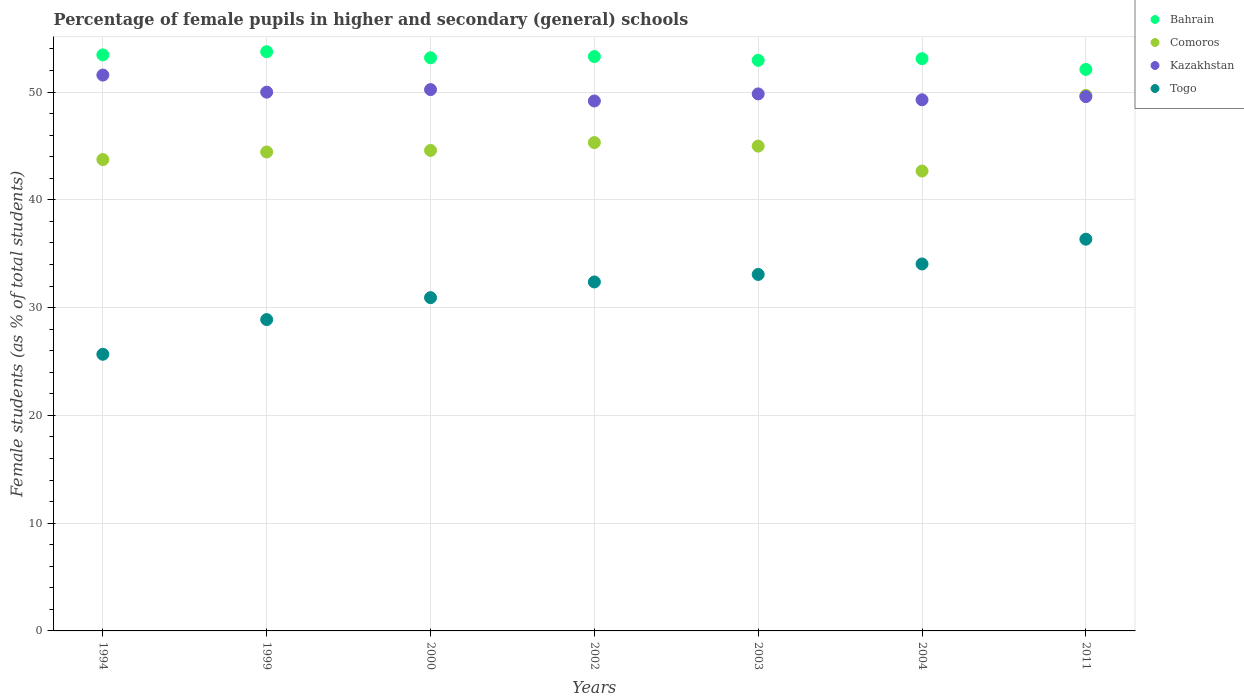How many different coloured dotlines are there?
Your answer should be very brief. 4. What is the percentage of female pupils in higher and secondary schools in Bahrain in 2002?
Make the answer very short. 53.3. Across all years, what is the maximum percentage of female pupils in higher and secondary schools in Comoros?
Ensure brevity in your answer.  49.69. Across all years, what is the minimum percentage of female pupils in higher and secondary schools in Kazakhstan?
Offer a terse response. 49.17. What is the total percentage of female pupils in higher and secondary schools in Bahrain in the graph?
Provide a succinct answer. 371.83. What is the difference between the percentage of female pupils in higher and secondary schools in Kazakhstan in 2003 and that in 2011?
Ensure brevity in your answer.  0.25. What is the difference between the percentage of female pupils in higher and secondary schools in Bahrain in 2011 and the percentage of female pupils in higher and secondary schools in Togo in 1994?
Your answer should be very brief. 26.43. What is the average percentage of female pupils in higher and secondary schools in Comoros per year?
Keep it short and to the point. 45.06. In the year 2000, what is the difference between the percentage of female pupils in higher and secondary schools in Togo and percentage of female pupils in higher and secondary schools in Kazakhstan?
Provide a succinct answer. -19.3. In how many years, is the percentage of female pupils in higher and secondary schools in Togo greater than 16 %?
Offer a terse response. 7. What is the ratio of the percentage of female pupils in higher and secondary schools in Comoros in 1994 to that in 2003?
Offer a very short reply. 0.97. Is the percentage of female pupils in higher and secondary schools in Kazakhstan in 2000 less than that in 2003?
Provide a short and direct response. No. What is the difference between the highest and the second highest percentage of female pupils in higher and secondary schools in Kazakhstan?
Make the answer very short. 1.35. What is the difference between the highest and the lowest percentage of female pupils in higher and secondary schools in Kazakhstan?
Provide a short and direct response. 2.4. Does the percentage of female pupils in higher and secondary schools in Bahrain monotonically increase over the years?
Your answer should be compact. No. Is the percentage of female pupils in higher and secondary schools in Kazakhstan strictly greater than the percentage of female pupils in higher and secondary schools in Bahrain over the years?
Offer a very short reply. No. How many years are there in the graph?
Give a very brief answer. 7. What is the difference between two consecutive major ticks on the Y-axis?
Your answer should be very brief. 10. Are the values on the major ticks of Y-axis written in scientific E-notation?
Keep it short and to the point. No. Does the graph contain grids?
Your answer should be compact. Yes. How many legend labels are there?
Your response must be concise. 4. How are the legend labels stacked?
Your response must be concise. Vertical. What is the title of the graph?
Make the answer very short. Percentage of female pupils in higher and secondary (general) schools. What is the label or title of the X-axis?
Keep it short and to the point. Years. What is the label or title of the Y-axis?
Your answer should be very brief. Female students (as % of total students). What is the Female students (as % of total students) in Bahrain in 1994?
Provide a short and direct response. 53.45. What is the Female students (as % of total students) in Comoros in 1994?
Offer a terse response. 43.74. What is the Female students (as % of total students) of Kazakhstan in 1994?
Offer a terse response. 51.58. What is the Female students (as % of total students) in Togo in 1994?
Keep it short and to the point. 25.67. What is the Female students (as % of total students) in Bahrain in 1999?
Provide a short and direct response. 53.75. What is the Female students (as % of total students) of Comoros in 1999?
Make the answer very short. 44.44. What is the Female students (as % of total students) in Kazakhstan in 1999?
Ensure brevity in your answer.  49.99. What is the Female students (as % of total students) in Togo in 1999?
Offer a terse response. 28.89. What is the Female students (as % of total students) of Bahrain in 2000?
Your answer should be compact. 53.18. What is the Female students (as % of total students) of Comoros in 2000?
Make the answer very short. 44.59. What is the Female students (as % of total students) of Kazakhstan in 2000?
Give a very brief answer. 50.23. What is the Female students (as % of total students) in Togo in 2000?
Offer a very short reply. 30.93. What is the Female students (as % of total students) of Bahrain in 2002?
Offer a very short reply. 53.3. What is the Female students (as % of total students) in Comoros in 2002?
Provide a succinct answer. 45.31. What is the Female students (as % of total students) in Kazakhstan in 2002?
Your answer should be very brief. 49.17. What is the Female students (as % of total students) of Togo in 2002?
Your response must be concise. 32.38. What is the Female students (as % of total students) of Bahrain in 2003?
Offer a very short reply. 52.95. What is the Female students (as % of total students) in Comoros in 2003?
Ensure brevity in your answer.  44.99. What is the Female students (as % of total students) of Kazakhstan in 2003?
Make the answer very short. 49.83. What is the Female students (as % of total students) of Togo in 2003?
Ensure brevity in your answer.  33.08. What is the Female students (as % of total students) in Bahrain in 2004?
Offer a terse response. 53.1. What is the Female students (as % of total students) in Comoros in 2004?
Your answer should be very brief. 42.67. What is the Female students (as % of total students) in Kazakhstan in 2004?
Offer a terse response. 49.29. What is the Female students (as % of total students) in Togo in 2004?
Provide a short and direct response. 34.05. What is the Female students (as % of total students) of Bahrain in 2011?
Your answer should be very brief. 52.1. What is the Female students (as % of total students) of Comoros in 2011?
Offer a very short reply. 49.69. What is the Female students (as % of total students) of Kazakhstan in 2011?
Give a very brief answer. 49.58. What is the Female students (as % of total students) in Togo in 2011?
Provide a succinct answer. 36.35. Across all years, what is the maximum Female students (as % of total students) in Bahrain?
Ensure brevity in your answer.  53.75. Across all years, what is the maximum Female students (as % of total students) in Comoros?
Your answer should be very brief. 49.69. Across all years, what is the maximum Female students (as % of total students) in Kazakhstan?
Your answer should be compact. 51.58. Across all years, what is the maximum Female students (as % of total students) of Togo?
Provide a succinct answer. 36.35. Across all years, what is the minimum Female students (as % of total students) of Bahrain?
Ensure brevity in your answer.  52.1. Across all years, what is the minimum Female students (as % of total students) of Comoros?
Offer a very short reply. 42.67. Across all years, what is the minimum Female students (as % of total students) of Kazakhstan?
Your response must be concise. 49.17. Across all years, what is the minimum Female students (as % of total students) in Togo?
Give a very brief answer. 25.67. What is the total Female students (as % of total students) in Bahrain in the graph?
Keep it short and to the point. 371.83. What is the total Female students (as % of total students) of Comoros in the graph?
Give a very brief answer. 315.43. What is the total Female students (as % of total students) in Kazakhstan in the graph?
Make the answer very short. 349.68. What is the total Female students (as % of total students) in Togo in the graph?
Offer a very short reply. 221.35. What is the difference between the Female students (as % of total students) in Bahrain in 1994 and that in 1999?
Provide a succinct answer. -0.3. What is the difference between the Female students (as % of total students) of Comoros in 1994 and that in 1999?
Keep it short and to the point. -0.7. What is the difference between the Female students (as % of total students) of Kazakhstan in 1994 and that in 1999?
Your response must be concise. 1.58. What is the difference between the Female students (as % of total students) in Togo in 1994 and that in 1999?
Keep it short and to the point. -3.22. What is the difference between the Female students (as % of total students) of Bahrain in 1994 and that in 2000?
Ensure brevity in your answer.  0.27. What is the difference between the Female students (as % of total students) in Comoros in 1994 and that in 2000?
Offer a terse response. -0.85. What is the difference between the Female students (as % of total students) of Kazakhstan in 1994 and that in 2000?
Provide a short and direct response. 1.35. What is the difference between the Female students (as % of total students) in Togo in 1994 and that in 2000?
Offer a very short reply. -5.25. What is the difference between the Female students (as % of total students) in Bahrain in 1994 and that in 2002?
Provide a succinct answer. 0.15. What is the difference between the Female students (as % of total students) in Comoros in 1994 and that in 2002?
Provide a short and direct response. -1.57. What is the difference between the Female students (as % of total students) of Kazakhstan in 1994 and that in 2002?
Your answer should be very brief. 2.4. What is the difference between the Female students (as % of total students) in Togo in 1994 and that in 2002?
Your response must be concise. -6.71. What is the difference between the Female students (as % of total students) of Bahrain in 1994 and that in 2003?
Give a very brief answer. 0.51. What is the difference between the Female students (as % of total students) of Comoros in 1994 and that in 2003?
Offer a terse response. -1.25. What is the difference between the Female students (as % of total students) in Kazakhstan in 1994 and that in 2003?
Your response must be concise. 1.75. What is the difference between the Female students (as % of total students) of Togo in 1994 and that in 2003?
Offer a terse response. -7.41. What is the difference between the Female students (as % of total students) in Bahrain in 1994 and that in 2004?
Your answer should be very brief. 0.35. What is the difference between the Female students (as % of total students) of Comoros in 1994 and that in 2004?
Offer a very short reply. 1.07. What is the difference between the Female students (as % of total students) of Kazakhstan in 1994 and that in 2004?
Offer a very short reply. 2.29. What is the difference between the Female students (as % of total students) in Togo in 1994 and that in 2004?
Offer a very short reply. -8.38. What is the difference between the Female students (as % of total students) of Bahrain in 1994 and that in 2011?
Your answer should be very brief. 1.35. What is the difference between the Female students (as % of total students) of Comoros in 1994 and that in 2011?
Make the answer very short. -5.95. What is the difference between the Female students (as % of total students) of Kazakhstan in 1994 and that in 2011?
Ensure brevity in your answer.  2. What is the difference between the Female students (as % of total students) of Togo in 1994 and that in 2011?
Your response must be concise. -10.68. What is the difference between the Female students (as % of total students) in Bahrain in 1999 and that in 2000?
Ensure brevity in your answer.  0.56. What is the difference between the Female students (as % of total students) of Comoros in 1999 and that in 2000?
Your response must be concise. -0.15. What is the difference between the Female students (as % of total students) in Kazakhstan in 1999 and that in 2000?
Make the answer very short. -0.24. What is the difference between the Female students (as % of total students) of Togo in 1999 and that in 2000?
Make the answer very short. -2.04. What is the difference between the Female students (as % of total students) in Bahrain in 1999 and that in 2002?
Your answer should be compact. 0.45. What is the difference between the Female students (as % of total students) in Comoros in 1999 and that in 2002?
Keep it short and to the point. -0.87. What is the difference between the Female students (as % of total students) in Kazakhstan in 1999 and that in 2002?
Provide a short and direct response. 0.82. What is the difference between the Female students (as % of total students) of Togo in 1999 and that in 2002?
Provide a short and direct response. -3.49. What is the difference between the Female students (as % of total students) of Bahrain in 1999 and that in 2003?
Keep it short and to the point. 0.8. What is the difference between the Female students (as % of total students) of Comoros in 1999 and that in 2003?
Your response must be concise. -0.54. What is the difference between the Female students (as % of total students) of Kazakhstan in 1999 and that in 2003?
Keep it short and to the point. 0.16. What is the difference between the Female students (as % of total students) in Togo in 1999 and that in 2003?
Your answer should be compact. -4.19. What is the difference between the Female students (as % of total students) in Bahrain in 1999 and that in 2004?
Offer a very short reply. 0.65. What is the difference between the Female students (as % of total students) in Comoros in 1999 and that in 2004?
Keep it short and to the point. 1.77. What is the difference between the Female students (as % of total students) in Kazakhstan in 1999 and that in 2004?
Ensure brevity in your answer.  0.71. What is the difference between the Female students (as % of total students) of Togo in 1999 and that in 2004?
Ensure brevity in your answer.  -5.16. What is the difference between the Female students (as % of total students) in Bahrain in 1999 and that in 2011?
Offer a terse response. 1.64. What is the difference between the Female students (as % of total students) of Comoros in 1999 and that in 2011?
Provide a succinct answer. -5.25. What is the difference between the Female students (as % of total students) of Kazakhstan in 1999 and that in 2011?
Your answer should be compact. 0.41. What is the difference between the Female students (as % of total students) in Togo in 1999 and that in 2011?
Your response must be concise. -7.46. What is the difference between the Female students (as % of total students) of Bahrain in 2000 and that in 2002?
Your answer should be compact. -0.11. What is the difference between the Female students (as % of total students) of Comoros in 2000 and that in 2002?
Provide a short and direct response. -0.73. What is the difference between the Female students (as % of total students) in Kazakhstan in 2000 and that in 2002?
Keep it short and to the point. 1.06. What is the difference between the Female students (as % of total students) of Togo in 2000 and that in 2002?
Give a very brief answer. -1.46. What is the difference between the Female students (as % of total students) of Bahrain in 2000 and that in 2003?
Your answer should be very brief. 0.24. What is the difference between the Female students (as % of total students) in Comoros in 2000 and that in 2003?
Your response must be concise. -0.4. What is the difference between the Female students (as % of total students) in Kazakhstan in 2000 and that in 2003?
Provide a succinct answer. 0.4. What is the difference between the Female students (as % of total students) in Togo in 2000 and that in 2003?
Your answer should be compact. -2.15. What is the difference between the Female students (as % of total students) in Bahrain in 2000 and that in 2004?
Keep it short and to the point. 0.09. What is the difference between the Female students (as % of total students) of Comoros in 2000 and that in 2004?
Keep it short and to the point. 1.91. What is the difference between the Female students (as % of total students) in Kazakhstan in 2000 and that in 2004?
Provide a short and direct response. 0.95. What is the difference between the Female students (as % of total students) of Togo in 2000 and that in 2004?
Keep it short and to the point. -3.13. What is the difference between the Female students (as % of total students) of Bahrain in 2000 and that in 2011?
Give a very brief answer. 1.08. What is the difference between the Female students (as % of total students) of Comoros in 2000 and that in 2011?
Provide a short and direct response. -5.11. What is the difference between the Female students (as % of total students) in Kazakhstan in 2000 and that in 2011?
Offer a very short reply. 0.65. What is the difference between the Female students (as % of total students) of Togo in 2000 and that in 2011?
Offer a very short reply. -5.42. What is the difference between the Female students (as % of total students) of Bahrain in 2002 and that in 2003?
Provide a succinct answer. 0.35. What is the difference between the Female students (as % of total students) in Comoros in 2002 and that in 2003?
Your answer should be very brief. 0.33. What is the difference between the Female students (as % of total students) of Kazakhstan in 2002 and that in 2003?
Offer a very short reply. -0.66. What is the difference between the Female students (as % of total students) in Togo in 2002 and that in 2003?
Give a very brief answer. -0.7. What is the difference between the Female students (as % of total students) in Bahrain in 2002 and that in 2004?
Provide a succinct answer. 0.2. What is the difference between the Female students (as % of total students) in Comoros in 2002 and that in 2004?
Offer a terse response. 2.64. What is the difference between the Female students (as % of total students) of Kazakhstan in 2002 and that in 2004?
Your answer should be very brief. -0.11. What is the difference between the Female students (as % of total students) in Togo in 2002 and that in 2004?
Keep it short and to the point. -1.67. What is the difference between the Female students (as % of total students) in Bahrain in 2002 and that in 2011?
Your response must be concise. 1.19. What is the difference between the Female students (as % of total students) of Comoros in 2002 and that in 2011?
Make the answer very short. -4.38. What is the difference between the Female students (as % of total students) in Kazakhstan in 2002 and that in 2011?
Your response must be concise. -0.41. What is the difference between the Female students (as % of total students) of Togo in 2002 and that in 2011?
Give a very brief answer. -3.97. What is the difference between the Female students (as % of total students) in Bahrain in 2003 and that in 2004?
Offer a terse response. -0.15. What is the difference between the Female students (as % of total students) of Comoros in 2003 and that in 2004?
Provide a succinct answer. 2.31. What is the difference between the Female students (as % of total students) in Kazakhstan in 2003 and that in 2004?
Make the answer very short. 0.55. What is the difference between the Female students (as % of total students) of Togo in 2003 and that in 2004?
Make the answer very short. -0.97. What is the difference between the Female students (as % of total students) in Bahrain in 2003 and that in 2011?
Give a very brief answer. 0.84. What is the difference between the Female students (as % of total students) in Comoros in 2003 and that in 2011?
Ensure brevity in your answer.  -4.71. What is the difference between the Female students (as % of total students) in Kazakhstan in 2003 and that in 2011?
Make the answer very short. 0.25. What is the difference between the Female students (as % of total students) in Togo in 2003 and that in 2011?
Ensure brevity in your answer.  -3.27. What is the difference between the Female students (as % of total students) in Bahrain in 2004 and that in 2011?
Offer a very short reply. 0.99. What is the difference between the Female students (as % of total students) of Comoros in 2004 and that in 2011?
Keep it short and to the point. -7.02. What is the difference between the Female students (as % of total students) in Kazakhstan in 2004 and that in 2011?
Ensure brevity in your answer.  -0.3. What is the difference between the Female students (as % of total students) in Togo in 2004 and that in 2011?
Provide a short and direct response. -2.3. What is the difference between the Female students (as % of total students) of Bahrain in 1994 and the Female students (as % of total students) of Comoros in 1999?
Ensure brevity in your answer.  9.01. What is the difference between the Female students (as % of total students) of Bahrain in 1994 and the Female students (as % of total students) of Kazakhstan in 1999?
Offer a terse response. 3.46. What is the difference between the Female students (as % of total students) in Bahrain in 1994 and the Female students (as % of total students) in Togo in 1999?
Give a very brief answer. 24.56. What is the difference between the Female students (as % of total students) in Comoros in 1994 and the Female students (as % of total students) in Kazakhstan in 1999?
Ensure brevity in your answer.  -6.26. What is the difference between the Female students (as % of total students) in Comoros in 1994 and the Female students (as % of total students) in Togo in 1999?
Keep it short and to the point. 14.85. What is the difference between the Female students (as % of total students) of Kazakhstan in 1994 and the Female students (as % of total students) of Togo in 1999?
Keep it short and to the point. 22.69. What is the difference between the Female students (as % of total students) in Bahrain in 1994 and the Female students (as % of total students) in Comoros in 2000?
Your answer should be compact. 8.86. What is the difference between the Female students (as % of total students) in Bahrain in 1994 and the Female students (as % of total students) in Kazakhstan in 2000?
Offer a very short reply. 3.22. What is the difference between the Female students (as % of total students) in Bahrain in 1994 and the Female students (as % of total students) in Togo in 2000?
Your answer should be very brief. 22.53. What is the difference between the Female students (as % of total students) in Comoros in 1994 and the Female students (as % of total students) in Kazakhstan in 2000?
Your response must be concise. -6.49. What is the difference between the Female students (as % of total students) in Comoros in 1994 and the Female students (as % of total students) in Togo in 2000?
Keep it short and to the point. 12.81. What is the difference between the Female students (as % of total students) in Kazakhstan in 1994 and the Female students (as % of total students) in Togo in 2000?
Give a very brief answer. 20.65. What is the difference between the Female students (as % of total students) of Bahrain in 1994 and the Female students (as % of total students) of Comoros in 2002?
Offer a very short reply. 8.14. What is the difference between the Female students (as % of total students) of Bahrain in 1994 and the Female students (as % of total students) of Kazakhstan in 2002?
Your response must be concise. 4.28. What is the difference between the Female students (as % of total students) in Bahrain in 1994 and the Female students (as % of total students) in Togo in 2002?
Offer a very short reply. 21.07. What is the difference between the Female students (as % of total students) in Comoros in 1994 and the Female students (as % of total students) in Kazakhstan in 2002?
Provide a succinct answer. -5.44. What is the difference between the Female students (as % of total students) of Comoros in 1994 and the Female students (as % of total students) of Togo in 2002?
Offer a very short reply. 11.36. What is the difference between the Female students (as % of total students) of Kazakhstan in 1994 and the Female students (as % of total students) of Togo in 2002?
Make the answer very short. 19.2. What is the difference between the Female students (as % of total students) in Bahrain in 1994 and the Female students (as % of total students) in Comoros in 2003?
Offer a very short reply. 8.47. What is the difference between the Female students (as % of total students) of Bahrain in 1994 and the Female students (as % of total students) of Kazakhstan in 2003?
Your response must be concise. 3.62. What is the difference between the Female students (as % of total students) in Bahrain in 1994 and the Female students (as % of total students) in Togo in 2003?
Your answer should be compact. 20.37. What is the difference between the Female students (as % of total students) in Comoros in 1994 and the Female students (as % of total students) in Kazakhstan in 2003?
Ensure brevity in your answer.  -6.09. What is the difference between the Female students (as % of total students) of Comoros in 1994 and the Female students (as % of total students) of Togo in 2003?
Provide a short and direct response. 10.66. What is the difference between the Female students (as % of total students) of Kazakhstan in 1994 and the Female students (as % of total students) of Togo in 2003?
Provide a succinct answer. 18.5. What is the difference between the Female students (as % of total students) in Bahrain in 1994 and the Female students (as % of total students) in Comoros in 2004?
Ensure brevity in your answer.  10.78. What is the difference between the Female students (as % of total students) of Bahrain in 1994 and the Female students (as % of total students) of Kazakhstan in 2004?
Your answer should be compact. 4.17. What is the difference between the Female students (as % of total students) in Bahrain in 1994 and the Female students (as % of total students) in Togo in 2004?
Your response must be concise. 19.4. What is the difference between the Female students (as % of total students) of Comoros in 1994 and the Female students (as % of total students) of Kazakhstan in 2004?
Keep it short and to the point. -5.55. What is the difference between the Female students (as % of total students) in Comoros in 1994 and the Female students (as % of total students) in Togo in 2004?
Ensure brevity in your answer.  9.69. What is the difference between the Female students (as % of total students) in Kazakhstan in 1994 and the Female students (as % of total students) in Togo in 2004?
Your answer should be very brief. 17.53. What is the difference between the Female students (as % of total students) of Bahrain in 1994 and the Female students (as % of total students) of Comoros in 2011?
Keep it short and to the point. 3.76. What is the difference between the Female students (as % of total students) in Bahrain in 1994 and the Female students (as % of total students) in Kazakhstan in 2011?
Offer a very short reply. 3.87. What is the difference between the Female students (as % of total students) in Bahrain in 1994 and the Female students (as % of total students) in Togo in 2011?
Your answer should be compact. 17.1. What is the difference between the Female students (as % of total students) in Comoros in 1994 and the Female students (as % of total students) in Kazakhstan in 2011?
Offer a very short reply. -5.84. What is the difference between the Female students (as % of total students) in Comoros in 1994 and the Female students (as % of total students) in Togo in 2011?
Your answer should be compact. 7.39. What is the difference between the Female students (as % of total students) in Kazakhstan in 1994 and the Female students (as % of total students) in Togo in 2011?
Provide a short and direct response. 15.23. What is the difference between the Female students (as % of total students) of Bahrain in 1999 and the Female students (as % of total students) of Comoros in 2000?
Provide a succinct answer. 9.16. What is the difference between the Female students (as % of total students) of Bahrain in 1999 and the Female students (as % of total students) of Kazakhstan in 2000?
Your response must be concise. 3.52. What is the difference between the Female students (as % of total students) in Bahrain in 1999 and the Female students (as % of total students) in Togo in 2000?
Offer a terse response. 22.82. What is the difference between the Female students (as % of total students) in Comoros in 1999 and the Female students (as % of total students) in Kazakhstan in 2000?
Your response must be concise. -5.79. What is the difference between the Female students (as % of total students) in Comoros in 1999 and the Female students (as % of total students) in Togo in 2000?
Your response must be concise. 13.52. What is the difference between the Female students (as % of total students) of Kazakhstan in 1999 and the Female students (as % of total students) of Togo in 2000?
Provide a succinct answer. 19.07. What is the difference between the Female students (as % of total students) of Bahrain in 1999 and the Female students (as % of total students) of Comoros in 2002?
Give a very brief answer. 8.43. What is the difference between the Female students (as % of total students) of Bahrain in 1999 and the Female students (as % of total students) of Kazakhstan in 2002?
Provide a short and direct response. 4.57. What is the difference between the Female students (as % of total students) of Bahrain in 1999 and the Female students (as % of total students) of Togo in 2002?
Your response must be concise. 21.37. What is the difference between the Female students (as % of total students) of Comoros in 1999 and the Female students (as % of total students) of Kazakhstan in 2002?
Make the answer very short. -4.73. What is the difference between the Female students (as % of total students) in Comoros in 1999 and the Female students (as % of total students) in Togo in 2002?
Your answer should be very brief. 12.06. What is the difference between the Female students (as % of total students) in Kazakhstan in 1999 and the Female students (as % of total students) in Togo in 2002?
Offer a very short reply. 17.61. What is the difference between the Female students (as % of total students) of Bahrain in 1999 and the Female students (as % of total students) of Comoros in 2003?
Your response must be concise. 8.76. What is the difference between the Female students (as % of total students) in Bahrain in 1999 and the Female students (as % of total students) in Kazakhstan in 2003?
Ensure brevity in your answer.  3.92. What is the difference between the Female students (as % of total students) in Bahrain in 1999 and the Female students (as % of total students) in Togo in 2003?
Provide a succinct answer. 20.67. What is the difference between the Female students (as % of total students) in Comoros in 1999 and the Female students (as % of total students) in Kazakhstan in 2003?
Your response must be concise. -5.39. What is the difference between the Female students (as % of total students) of Comoros in 1999 and the Female students (as % of total students) of Togo in 2003?
Ensure brevity in your answer.  11.36. What is the difference between the Female students (as % of total students) in Kazakhstan in 1999 and the Female students (as % of total students) in Togo in 2003?
Your response must be concise. 16.91. What is the difference between the Female students (as % of total students) in Bahrain in 1999 and the Female students (as % of total students) in Comoros in 2004?
Provide a short and direct response. 11.07. What is the difference between the Female students (as % of total students) in Bahrain in 1999 and the Female students (as % of total students) in Kazakhstan in 2004?
Your answer should be compact. 4.46. What is the difference between the Female students (as % of total students) in Bahrain in 1999 and the Female students (as % of total students) in Togo in 2004?
Provide a short and direct response. 19.7. What is the difference between the Female students (as % of total students) of Comoros in 1999 and the Female students (as % of total students) of Kazakhstan in 2004?
Give a very brief answer. -4.84. What is the difference between the Female students (as % of total students) of Comoros in 1999 and the Female students (as % of total students) of Togo in 2004?
Ensure brevity in your answer.  10.39. What is the difference between the Female students (as % of total students) in Kazakhstan in 1999 and the Female students (as % of total students) in Togo in 2004?
Give a very brief answer. 15.94. What is the difference between the Female students (as % of total students) in Bahrain in 1999 and the Female students (as % of total students) in Comoros in 2011?
Keep it short and to the point. 4.06. What is the difference between the Female students (as % of total students) of Bahrain in 1999 and the Female students (as % of total students) of Kazakhstan in 2011?
Offer a terse response. 4.17. What is the difference between the Female students (as % of total students) of Bahrain in 1999 and the Female students (as % of total students) of Togo in 2011?
Provide a succinct answer. 17.4. What is the difference between the Female students (as % of total students) in Comoros in 1999 and the Female students (as % of total students) in Kazakhstan in 2011?
Offer a very short reply. -5.14. What is the difference between the Female students (as % of total students) in Comoros in 1999 and the Female students (as % of total students) in Togo in 2011?
Ensure brevity in your answer.  8.09. What is the difference between the Female students (as % of total students) in Kazakhstan in 1999 and the Female students (as % of total students) in Togo in 2011?
Provide a short and direct response. 13.65. What is the difference between the Female students (as % of total students) in Bahrain in 2000 and the Female students (as % of total students) in Comoros in 2002?
Your response must be concise. 7.87. What is the difference between the Female students (as % of total students) in Bahrain in 2000 and the Female students (as % of total students) in Kazakhstan in 2002?
Keep it short and to the point. 4.01. What is the difference between the Female students (as % of total students) in Bahrain in 2000 and the Female students (as % of total students) in Togo in 2002?
Provide a short and direct response. 20.8. What is the difference between the Female students (as % of total students) of Comoros in 2000 and the Female students (as % of total students) of Kazakhstan in 2002?
Provide a succinct answer. -4.59. What is the difference between the Female students (as % of total students) of Comoros in 2000 and the Female students (as % of total students) of Togo in 2002?
Your response must be concise. 12.2. What is the difference between the Female students (as % of total students) of Kazakhstan in 2000 and the Female students (as % of total students) of Togo in 2002?
Ensure brevity in your answer.  17.85. What is the difference between the Female students (as % of total students) in Bahrain in 2000 and the Female students (as % of total students) in Comoros in 2003?
Offer a very short reply. 8.2. What is the difference between the Female students (as % of total students) of Bahrain in 2000 and the Female students (as % of total students) of Kazakhstan in 2003?
Give a very brief answer. 3.35. What is the difference between the Female students (as % of total students) in Bahrain in 2000 and the Female students (as % of total students) in Togo in 2003?
Make the answer very short. 20.11. What is the difference between the Female students (as % of total students) of Comoros in 2000 and the Female students (as % of total students) of Kazakhstan in 2003?
Keep it short and to the point. -5.24. What is the difference between the Female students (as % of total students) of Comoros in 2000 and the Female students (as % of total students) of Togo in 2003?
Provide a short and direct response. 11.51. What is the difference between the Female students (as % of total students) of Kazakhstan in 2000 and the Female students (as % of total students) of Togo in 2003?
Your answer should be very brief. 17.15. What is the difference between the Female students (as % of total students) of Bahrain in 2000 and the Female students (as % of total students) of Comoros in 2004?
Ensure brevity in your answer.  10.51. What is the difference between the Female students (as % of total students) of Bahrain in 2000 and the Female students (as % of total students) of Kazakhstan in 2004?
Provide a short and direct response. 3.9. What is the difference between the Female students (as % of total students) of Bahrain in 2000 and the Female students (as % of total students) of Togo in 2004?
Offer a terse response. 19.13. What is the difference between the Female students (as % of total students) of Comoros in 2000 and the Female students (as % of total students) of Kazakhstan in 2004?
Provide a succinct answer. -4.7. What is the difference between the Female students (as % of total students) of Comoros in 2000 and the Female students (as % of total students) of Togo in 2004?
Ensure brevity in your answer.  10.54. What is the difference between the Female students (as % of total students) in Kazakhstan in 2000 and the Female students (as % of total students) in Togo in 2004?
Provide a short and direct response. 16.18. What is the difference between the Female students (as % of total students) of Bahrain in 2000 and the Female students (as % of total students) of Comoros in 2011?
Your answer should be compact. 3.49. What is the difference between the Female students (as % of total students) of Bahrain in 2000 and the Female students (as % of total students) of Kazakhstan in 2011?
Make the answer very short. 3.6. What is the difference between the Female students (as % of total students) of Bahrain in 2000 and the Female students (as % of total students) of Togo in 2011?
Give a very brief answer. 16.84. What is the difference between the Female students (as % of total students) in Comoros in 2000 and the Female students (as % of total students) in Kazakhstan in 2011?
Offer a very short reply. -4.99. What is the difference between the Female students (as % of total students) in Comoros in 2000 and the Female students (as % of total students) in Togo in 2011?
Provide a succinct answer. 8.24. What is the difference between the Female students (as % of total students) of Kazakhstan in 2000 and the Female students (as % of total students) of Togo in 2011?
Make the answer very short. 13.88. What is the difference between the Female students (as % of total students) of Bahrain in 2002 and the Female students (as % of total students) of Comoros in 2003?
Offer a terse response. 8.31. What is the difference between the Female students (as % of total students) of Bahrain in 2002 and the Female students (as % of total students) of Kazakhstan in 2003?
Your answer should be very brief. 3.47. What is the difference between the Female students (as % of total students) of Bahrain in 2002 and the Female students (as % of total students) of Togo in 2003?
Give a very brief answer. 20.22. What is the difference between the Female students (as % of total students) in Comoros in 2002 and the Female students (as % of total students) in Kazakhstan in 2003?
Provide a short and direct response. -4.52. What is the difference between the Female students (as % of total students) of Comoros in 2002 and the Female students (as % of total students) of Togo in 2003?
Your response must be concise. 12.23. What is the difference between the Female students (as % of total students) in Kazakhstan in 2002 and the Female students (as % of total students) in Togo in 2003?
Provide a short and direct response. 16.1. What is the difference between the Female students (as % of total students) in Bahrain in 2002 and the Female students (as % of total students) in Comoros in 2004?
Keep it short and to the point. 10.62. What is the difference between the Female students (as % of total students) in Bahrain in 2002 and the Female students (as % of total students) in Kazakhstan in 2004?
Your answer should be very brief. 4.01. What is the difference between the Female students (as % of total students) of Bahrain in 2002 and the Female students (as % of total students) of Togo in 2004?
Keep it short and to the point. 19.25. What is the difference between the Female students (as % of total students) in Comoros in 2002 and the Female students (as % of total students) in Kazakhstan in 2004?
Make the answer very short. -3.97. What is the difference between the Female students (as % of total students) of Comoros in 2002 and the Female students (as % of total students) of Togo in 2004?
Your answer should be compact. 11.26. What is the difference between the Female students (as % of total students) of Kazakhstan in 2002 and the Female students (as % of total students) of Togo in 2004?
Provide a succinct answer. 15.12. What is the difference between the Female students (as % of total students) of Bahrain in 2002 and the Female students (as % of total students) of Comoros in 2011?
Give a very brief answer. 3.6. What is the difference between the Female students (as % of total students) of Bahrain in 2002 and the Female students (as % of total students) of Kazakhstan in 2011?
Your answer should be very brief. 3.72. What is the difference between the Female students (as % of total students) in Bahrain in 2002 and the Female students (as % of total students) in Togo in 2011?
Keep it short and to the point. 16.95. What is the difference between the Female students (as % of total students) in Comoros in 2002 and the Female students (as % of total students) in Kazakhstan in 2011?
Provide a short and direct response. -4.27. What is the difference between the Female students (as % of total students) in Comoros in 2002 and the Female students (as % of total students) in Togo in 2011?
Your answer should be compact. 8.96. What is the difference between the Female students (as % of total students) of Kazakhstan in 2002 and the Female students (as % of total students) of Togo in 2011?
Your answer should be compact. 12.83. What is the difference between the Female students (as % of total students) in Bahrain in 2003 and the Female students (as % of total students) in Comoros in 2004?
Give a very brief answer. 10.27. What is the difference between the Female students (as % of total students) of Bahrain in 2003 and the Female students (as % of total students) of Kazakhstan in 2004?
Your response must be concise. 3.66. What is the difference between the Female students (as % of total students) of Bahrain in 2003 and the Female students (as % of total students) of Togo in 2004?
Keep it short and to the point. 18.89. What is the difference between the Female students (as % of total students) in Comoros in 2003 and the Female students (as % of total students) in Kazakhstan in 2004?
Your answer should be compact. -4.3. What is the difference between the Female students (as % of total students) of Comoros in 2003 and the Female students (as % of total students) of Togo in 2004?
Your response must be concise. 10.93. What is the difference between the Female students (as % of total students) of Kazakhstan in 2003 and the Female students (as % of total students) of Togo in 2004?
Provide a succinct answer. 15.78. What is the difference between the Female students (as % of total students) in Bahrain in 2003 and the Female students (as % of total students) in Comoros in 2011?
Your response must be concise. 3.25. What is the difference between the Female students (as % of total students) of Bahrain in 2003 and the Female students (as % of total students) of Kazakhstan in 2011?
Give a very brief answer. 3.37. What is the difference between the Female students (as % of total students) of Bahrain in 2003 and the Female students (as % of total students) of Togo in 2011?
Give a very brief answer. 16.6. What is the difference between the Female students (as % of total students) in Comoros in 2003 and the Female students (as % of total students) in Kazakhstan in 2011?
Provide a succinct answer. -4.59. What is the difference between the Female students (as % of total students) in Comoros in 2003 and the Female students (as % of total students) in Togo in 2011?
Provide a succinct answer. 8.64. What is the difference between the Female students (as % of total students) in Kazakhstan in 2003 and the Female students (as % of total students) in Togo in 2011?
Make the answer very short. 13.48. What is the difference between the Female students (as % of total students) of Bahrain in 2004 and the Female students (as % of total students) of Comoros in 2011?
Provide a succinct answer. 3.41. What is the difference between the Female students (as % of total students) in Bahrain in 2004 and the Female students (as % of total students) in Kazakhstan in 2011?
Make the answer very short. 3.52. What is the difference between the Female students (as % of total students) in Bahrain in 2004 and the Female students (as % of total students) in Togo in 2011?
Your response must be concise. 16.75. What is the difference between the Female students (as % of total students) of Comoros in 2004 and the Female students (as % of total students) of Kazakhstan in 2011?
Offer a very short reply. -6.91. What is the difference between the Female students (as % of total students) in Comoros in 2004 and the Female students (as % of total students) in Togo in 2011?
Keep it short and to the point. 6.32. What is the difference between the Female students (as % of total students) in Kazakhstan in 2004 and the Female students (as % of total students) in Togo in 2011?
Provide a succinct answer. 12.94. What is the average Female students (as % of total students) in Bahrain per year?
Make the answer very short. 53.12. What is the average Female students (as % of total students) of Comoros per year?
Offer a very short reply. 45.06. What is the average Female students (as % of total students) of Kazakhstan per year?
Ensure brevity in your answer.  49.95. What is the average Female students (as % of total students) of Togo per year?
Make the answer very short. 31.62. In the year 1994, what is the difference between the Female students (as % of total students) in Bahrain and Female students (as % of total students) in Comoros?
Your response must be concise. 9.71. In the year 1994, what is the difference between the Female students (as % of total students) in Bahrain and Female students (as % of total students) in Kazakhstan?
Offer a very short reply. 1.87. In the year 1994, what is the difference between the Female students (as % of total students) of Bahrain and Female students (as % of total students) of Togo?
Give a very brief answer. 27.78. In the year 1994, what is the difference between the Female students (as % of total students) of Comoros and Female students (as % of total students) of Kazakhstan?
Offer a very short reply. -7.84. In the year 1994, what is the difference between the Female students (as % of total students) in Comoros and Female students (as % of total students) in Togo?
Your answer should be compact. 18.07. In the year 1994, what is the difference between the Female students (as % of total students) in Kazakhstan and Female students (as % of total students) in Togo?
Your response must be concise. 25.91. In the year 1999, what is the difference between the Female students (as % of total students) of Bahrain and Female students (as % of total students) of Comoros?
Offer a very short reply. 9.31. In the year 1999, what is the difference between the Female students (as % of total students) in Bahrain and Female students (as % of total students) in Kazakhstan?
Provide a succinct answer. 3.75. In the year 1999, what is the difference between the Female students (as % of total students) in Bahrain and Female students (as % of total students) in Togo?
Offer a very short reply. 24.86. In the year 1999, what is the difference between the Female students (as % of total students) in Comoros and Female students (as % of total students) in Kazakhstan?
Provide a succinct answer. -5.55. In the year 1999, what is the difference between the Female students (as % of total students) of Comoros and Female students (as % of total students) of Togo?
Offer a terse response. 15.55. In the year 1999, what is the difference between the Female students (as % of total students) in Kazakhstan and Female students (as % of total students) in Togo?
Offer a terse response. 21.1. In the year 2000, what is the difference between the Female students (as % of total students) of Bahrain and Female students (as % of total students) of Comoros?
Your response must be concise. 8.6. In the year 2000, what is the difference between the Female students (as % of total students) of Bahrain and Female students (as % of total students) of Kazakhstan?
Your answer should be compact. 2.95. In the year 2000, what is the difference between the Female students (as % of total students) in Bahrain and Female students (as % of total students) in Togo?
Ensure brevity in your answer.  22.26. In the year 2000, what is the difference between the Female students (as % of total students) in Comoros and Female students (as % of total students) in Kazakhstan?
Make the answer very short. -5.64. In the year 2000, what is the difference between the Female students (as % of total students) in Comoros and Female students (as % of total students) in Togo?
Provide a short and direct response. 13.66. In the year 2000, what is the difference between the Female students (as % of total students) in Kazakhstan and Female students (as % of total students) in Togo?
Keep it short and to the point. 19.3. In the year 2002, what is the difference between the Female students (as % of total students) in Bahrain and Female students (as % of total students) in Comoros?
Your answer should be compact. 7.98. In the year 2002, what is the difference between the Female students (as % of total students) in Bahrain and Female students (as % of total students) in Kazakhstan?
Ensure brevity in your answer.  4.12. In the year 2002, what is the difference between the Female students (as % of total students) in Bahrain and Female students (as % of total students) in Togo?
Make the answer very short. 20.91. In the year 2002, what is the difference between the Female students (as % of total students) of Comoros and Female students (as % of total students) of Kazakhstan?
Give a very brief answer. -3.86. In the year 2002, what is the difference between the Female students (as % of total students) in Comoros and Female students (as % of total students) in Togo?
Offer a terse response. 12.93. In the year 2002, what is the difference between the Female students (as % of total students) in Kazakhstan and Female students (as % of total students) in Togo?
Keep it short and to the point. 16.79. In the year 2003, what is the difference between the Female students (as % of total students) in Bahrain and Female students (as % of total students) in Comoros?
Provide a short and direct response. 7.96. In the year 2003, what is the difference between the Female students (as % of total students) in Bahrain and Female students (as % of total students) in Kazakhstan?
Your answer should be very brief. 3.11. In the year 2003, what is the difference between the Female students (as % of total students) of Bahrain and Female students (as % of total students) of Togo?
Provide a succinct answer. 19.87. In the year 2003, what is the difference between the Female students (as % of total students) in Comoros and Female students (as % of total students) in Kazakhstan?
Provide a succinct answer. -4.85. In the year 2003, what is the difference between the Female students (as % of total students) in Comoros and Female students (as % of total students) in Togo?
Keep it short and to the point. 11.91. In the year 2003, what is the difference between the Female students (as % of total students) in Kazakhstan and Female students (as % of total students) in Togo?
Your response must be concise. 16.75. In the year 2004, what is the difference between the Female students (as % of total students) in Bahrain and Female students (as % of total students) in Comoros?
Keep it short and to the point. 10.43. In the year 2004, what is the difference between the Female students (as % of total students) in Bahrain and Female students (as % of total students) in Kazakhstan?
Make the answer very short. 3.81. In the year 2004, what is the difference between the Female students (as % of total students) of Bahrain and Female students (as % of total students) of Togo?
Offer a very short reply. 19.05. In the year 2004, what is the difference between the Female students (as % of total students) in Comoros and Female students (as % of total students) in Kazakhstan?
Keep it short and to the point. -6.61. In the year 2004, what is the difference between the Female students (as % of total students) of Comoros and Female students (as % of total students) of Togo?
Provide a succinct answer. 8.62. In the year 2004, what is the difference between the Female students (as % of total students) in Kazakhstan and Female students (as % of total students) in Togo?
Provide a succinct answer. 15.23. In the year 2011, what is the difference between the Female students (as % of total students) in Bahrain and Female students (as % of total students) in Comoros?
Your answer should be very brief. 2.41. In the year 2011, what is the difference between the Female students (as % of total students) in Bahrain and Female students (as % of total students) in Kazakhstan?
Your response must be concise. 2.52. In the year 2011, what is the difference between the Female students (as % of total students) in Bahrain and Female students (as % of total students) in Togo?
Your response must be concise. 15.76. In the year 2011, what is the difference between the Female students (as % of total students) of Comoros and Female students (as % of total students) of Kazakhstan?
Make the answer very short. 0.11. In the year 2011, what is the difference between the Female students (as % of total students) in Comoros and Female students (as % of total students) in Togo?
Your answer should be compact. 13.34. In the year 2011, what is the difference between the Female students (as % of total students) of Kazakhstan and Female students (as % of total students) of Togo?
Offer a terse response. 13.23. What is the ratio of the Female students (as % of total students) in Bahrain in 1994 to that in 1999?
Ensure brevity in your answer.  0.99. What is the ratio of the Female students (as % of total students) in Comoros in 1994 to that in 1999?
Your answer should be very brief. 0.98. What is the ratio of the Female students (as % of total students) of Kazakhstan in 1994 to that in 1999?
Provide a short and direct response. 1.03. What is the ratio of the Female students (as % of total students) of Togo in 1994 to that in 1999?
Offer a terse response. 0.89. What is the ratio of the Female students (as % of total students) of Bahrain in 1994 to that in 2000?
Ensure brevity in your answer.  1. What is the ratio of the Female students (as % of total students) in Kazakhstan in 1994 to that in 2000?
Your answer should be very brief. 1.03. What is the ratio of the Female students (as % of total students) in Togo in 1994 to that in 2000?
Keep it short and to the point. 0.83. What is the ratio of the Female students (as % of total students) in Bahrain in 1994 to that in 2002?
Your response must be concise. 1. What is the ratio of the Female students (as % of total students) in Comoros in 1994 to that in 2002?
Make the answer very short. 0.97. What is the ratio of the Female students (as % of total students) of Kazakhstan in 1994 to that in 2002?
Give a very brief answer. 1.05. What is the ratio of the Female students (as % of total students) in Togo in 1994 to that in 2002?
Your answer should be very brief. 0.79. What is the ratio of the Female students (as % of total students) of Bahrain in 1994 to that in 2003?
Your answer should be very brief. 1.01. What is the ratio of the Female students (as % of total students) of Comoros in 1994 to that in 2003?
Provide a succinct answer. 0.97. What is the ratio of the Female students (as % of total students) of Kazakhstan in 1994 to that in 2003?
Keep it short and to the point. 1.04. What is the ratio of the Female students (as % of total students) of Togo in 1994 to that in 2003?
Ensure brevity in your answer.  0.78. What is the ratio of the Female students (as % of total students) of Bahrain in 1994 to that in 2004?
Your response must be concise. 1.01. What is the ratio of the Female students (as % of total students) in Comoros in 1994 to that in 2004?
Provide a short and direct response. 1.02. What is the ratio of the Female students (as % of total students) in Kazakhstan in 1994 to that in 2004?
Your response must be concise. 1.05. What is the ratio of the Female students (as % of total students) in Togo in 1994 to that in 2004?
Ensure brevity in your answer.  0.75. What is the ratio of the Female students (as % of total students) in Bahrain in 1994 to that in 2011?
Your response must be concise. 1.03. What is the ratio of the Female students (as % of total students) of Comoros in 1994 to that in 2011?
Keep it short and to the point. 0.88. What is the ratio of the Female students (as % of total students) in Kazakhstan in 1994 to that in 2011?
Your answer should be very brief. 1.04. What is the ratio of the Female students (as % of total students) of Togo in 1994 to that in 2011?
Give a very brief answer. 0.71. What is the ratio of the Female students (as % of total students) in Bahrain in 1999 to that in 2000?
Offer a very short reply. 1.01. What is the ratio of the Female students (as % of total students) of Kazakhstan in 1999 to that in 2000?
Offer a terse response. 1. What is the ratio of the Female students (as % of total students) of Togo in 1999 to that in 2000?
Give a very brief answer. 0.93. What is the ratio of the Female students (as % of total students) in Bahrain in 1999 to that in 2002?
Offer a very short reply. 1.01. What is the ratio of the Female students (as % of total students) of Comoros in 1999 to that in 2002?
Provide a succinct answer. 0.98. What is the ratio of the Female students (as % of total students) in Kazakhstan in 1999 to that in 2002?
Make the answer very short. 1.02. What is the ratio of the Female students (as % of total students) of Togo in 1999 to that in 2002?
Provide a succinct answer. 0.89. What is the ratio of the Female students (as % of total students) of Bahrain in 1999 to that in 2003?
Make the answer very short. 1.02. What is the ratio of the Female students (as % of total students) in Comoros in 1999 to that in 2003?
Give a very brief answer. 0.99. What is the ratio of the Female students (as % of total students) in Togo in 1999 to that in 2003?
Your response must be concise. 0.87. What is the ratio of the Female students (as % of total students) in Bahrain in 1999 to that in 2004?
Offer a terse response. 1.01. What is the ratio of the Female students (as % of total students) in Comoros in 1999 to that in 2004?
Keep it short and to the point. 1.04. What is the ratio of the Female students (as % of total students) of Kazakhstan in 1999 to that in 2004?
Ensure brevity in your answer.  1.01. What is the ratio of the Female students (as % of total students) in Togo in 1999 to that in 2004?
Your answer should be compact. 0.85. What is the ratio of the Female students (as % of total students) in Bahrain in 1999 to that in 2011?
Provide a succinct answer. 1.03. What is the ratio of the Female students (as % of total students) in Comoros in 1999 to that in 2011?
Ensure brevity in your answer.  0.89. What is the ratio of the Female students (as % of total students) in Kazakhstan in 1999 to that in 2011?
Provide a short and direct response. 1.01. What is the ratio of the Female students (as % of total students) of Togo in 1999 to that in 2011?
Offer a very short reply. 0.79. What is the ratio of the Female students (as % of total students) in Kazakhstan in 2000 to that in 2002?
Offer a very short reply. 1.02. What is the ratio of the Female students (as % of total students) of Togo in 2000 to that in 2002?
Give a very brief answer. 0.95. What is the ratio of the Female students (as % of total students) of Togo in 2000 to that in 2003?
Provide a succinct answer. 0.93. What is the ratio of the Female students (as % of total students) of Bahrain in 2000 to that in 2004?
Your answer should be compact. 1. What is the ratio of the Female students (as % of total students) in Comoros in 2000 to that in 2004?
Give a very brief answer. 1.04. What is the ratio of the Female students (as % of total students) in Kazakhstan in 2000 to that in 2004?
Offer a terse response. 1.02. What is the ratio of the Female students (as % of total students) of Togo in 2000 to that in 2004?
Make the answer very short. 0.91. What is the ratio of the Female students (as % of total students) in Bahrain in 2000 to that in 2011?
Make the answer very short. 1.02. What is the ratio of the Female students (as % of total students) in Comoros in 2000 to that in 2011?
Your answer should be compact. 0.9. What is the ratio of the Female students (as % of total students) in Kazakhstan in 2000 to that in 2011?
Your response must be concise. 1.01. What is the ratio of the Female students (as % of total students) in Togo in 2000 to that in 2011?
Make the answer very short. 0.85. What is the ratio of the Female students (as % of total students) of Bahrain in 2002 to that in 2003?
Provide a succinct answer. 1.01. What is the ratio of the Female students (as % of total students) of Comoros in 2002 to that in 2003?
Your response must be concise. 1.01. What is the ratio of the Female students (as % of total students) of Togo in 2002 to that in 2003?
Provide a short and direct response. 0.98. What is the ratio of the Female students (as % of total students) in Comoros in 2002 to that in 2004?
Make the answer very short. 1.06. What is the ratio of the Female students (as % of total students) of Togo in 2002 to that in 2004?
Offer a terse response. 0.95. What is the ratio of the Female students (as % of total students) of Bahrain in 2002 to that in 2011?
Make the answer very short. 1.02. What is the ratio of the Female students (as % of total students) of Comoros in 2002 to that in 2011?
Offer a terse response. 0.91. What is the ratio of the Female students (as % of total students) of Togo in 2002 to that in 2011?
Make the answer very short. 0.89. What is the ratio of the Female students (as % of total students) in Comoros in 2003 to that in 2004?
Your answer should be compact. 1.05. What is the ratio of the Female students (as % of total students) in Kazakhstan in 2003 to that in 2004?
Provide a succinct answer. 1.01. What is the ratio of the Female students (as % of total students) of Togo in 2003 to that in 2004?
Keep it short and to the point. 0.97. What is the ratio of the Female students (as % of total students) of Bahrain in 2003 to that in 2011?
Your answer should be very brief. 1.02. What is the ratio of the Female students (as % of total students) of Comoros in 2003 to that in 2011?
Offer a terse response. 0.91. What is the ratio of the Female students (as % of total students) in Kazakhstan in 2003 to that in 2011?
Keep it short and to the point. 1.01. What is the ratio of the Female students (as % of total students) in Togo in 2003 to that in 2011?
Give a very brief answer. 0.91. What is the ratio of the Female students (as % of total students) of Bahrain in 2004 to that in 2011?
Provide a succinct answer. 1.02. What is the ratio of the Female students (as % of total students) of Comoros in 2004 to that in 2011?
Your answer should be very brief. 0.86. What is the ratio of the Female students (as % of total students) in Kazakhstan in 2004 to that in 2011?
Offer a very short reply. 0.99. What is the ratio of the Female students (as % of total students) of Togo in 2004 to that in 2011?
Keep it short and to the point. 0.94. What is the difference between the highest and the second highest Female students (as % of total students) in Bahrain?
Offer a terse response. 0.3. What is the difference between the highest and the second highest Female students (as % of total students) of Comoros?
Provide a succinct answer. 4.38. What is the difference between the highest and the second highest Female students (as % of total students) in Kazakhstan?
Your answer should be very brief. 1.35. What is the difference between the highest and the second highest Female students (as % of total students) in Togo?
Ensure brevity in your answer.  2.3. What is the difference between the highest and the lowest Female students (as % of total students) in Bahrain?
Provide a short and direct response. 1.64. What is the difference between the highest and the lowest Female students (as % of total students) of Comoros?
Provide a short and direct response. 7.02. What is the difference between the highest and the lowest Female students (as % of total students) in Kazakhstan?
Provide a short and direct response. 2.4. What is the difference between the highest and the lowest Female students (as % of total students) of Togo?
Give a very brief answer. 10.68. 